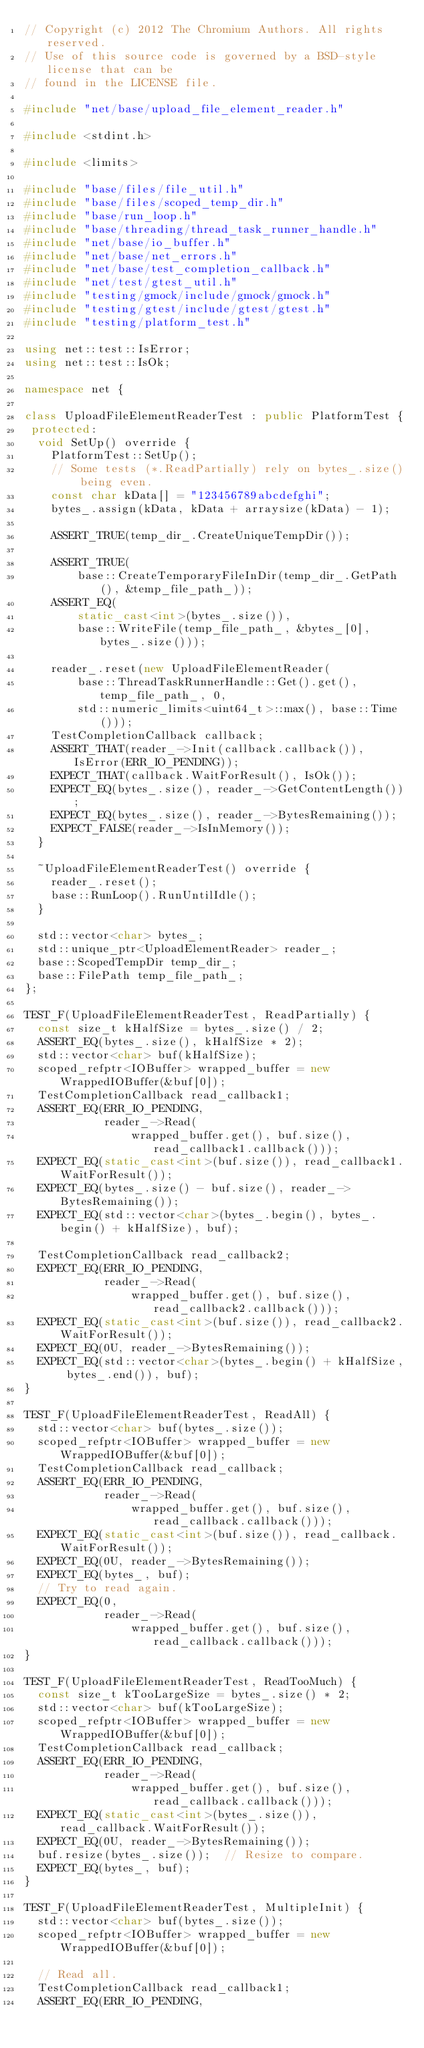<code> <loc_0><loc_0><loc_500><loc_500><_C++_>// Copyright (c) 2012 The Chromium Authors. All rights reserved.
// Use of this source code is governed by a BSD-style license that can be
// found in the LICENSE file.

#include "net/base/upload_file_element_reader.h"

#include <stdint.h>

#include <limits>

#include "base/files/file_util.h"
#include "base/files/scoped_temp_dir.h"
#include "base/run_loop.h"
#include "base/threading/thread_task_runner_handle.h"
#include "net/base/io_buffer.h"
#include "net/base/net_errors.h"
#include "net/base/test_completion_callback.h"
#include "net/test/gtest_util.h"
#include "testing/gmock/include/gmock/gmock.h"
#include "testing/gtest/include/gtest/gtest.h"
#include "testing/platform_test.h"

using net::test::IsError;
using net::test::IsOk;

namespace net {

class UploadFileElementReaderTest : public PlatformTest {
 protected:
  void SetUp() override {
    PlatformTest::SetUp();
    // Some tests (*.ReadPartially) rely on bytes_.size() being even.
    const char kData[] = "123456789abcdefghi";
    bytes_.assign(kData, kData + arraysize(kData) - 1);

    ASSERT_TRUE(temp_dir_.CreateUniqueTempDir());

    ASSERT_TRUE(
        base::CreateTemporaryFileInDir(temp_dir_.GetPath(), &temp_file_path_));
    ASSERT_EQ(
        static_cast<int>(bytes_.size()),
        base::WriteFile(temp_file_path_, &bytes_[0], bytes_.size()));

    reader_.reset(new UploadFileElementReader(
        base::ThreadTaskRunnerHandle::Get().get(), temp_file_path_, 0,
        std::numeric_limits<uint64_t>::max(), base::Time()));
    TestCompletionCallback callback;
    ASSERT_THAT(reader_->Init(callback.callback()), IsError(ERR_IO_PENDING));
    EXPECT_THAT(callback.WaitForResult(), IsOk());
    EXPECT_EQ(bytes_.size(), reader_->GetContentLength());
    EXPECT_EQ(bytes_.size(), reader_->BytesRemaining());
    EXPECT_FALSE(reader_->IsInMemory());
  }

  ~UploadFileElementReaderTest() override {
    reader_.reset();
    base::RunLoop().RunUntilIdle();
  }

  std::vector<char> bytes_;
  std::unique_ptr<UploadElementReader> reader_;
  base::ScopedTempDir temp_dir_;
  base::FilePath temp_file_path_;
};

TEST_F(UploadFileElementReaderTest, ReadPartially) {
  const size_t kHalfSize = bytes_.size() / 2;
  ASSERT_EQ(bytes_.size(), kHalfSize * 2);
  std::vector<char> buf(kHalfSize);
  scoped_refptr<IOBuffer> wrapped_buffer = new WrappedIOBuffer(&buf[0]);
  TestCompletionCallback read_callback1;
  ASSERT_EQ(ERR_IO_PENDING,
            reader_->Read(
                wrapped_buffer.get(), buf.size(), read_callback1.callback()));
  EXPECT_EQ(static_cast<int>(buf.size()), read_callback1.WaitForResult());
  EXPECT_EQ(bytes_.size() - buf.size(), reader_->BytesRemaining());
  EXPECT_EQ(std::vector<char>(bytes_.begin(), bytes_.begin() + kHalfSize), buf);

  TestCompletionCallback read_callback2;
  EXPECT_EQ(ERR_IO_PENDING,
            reader_->Read(
                wrapped_buffer.get(), buf.size(), read_callback2.callback()));
  EXPECT_EQ(static_cast<int>(buf.size()), read_callback2.WaitForResult());
  EXPECT_EQ(0U, reader_->BytesRemaining());
  EXPECT_EQ(std::vector<char>(bytes_.begin() + kHalfSize, bytes_.end()), buf);
}

TEST_F(UploadFileElementReaderTest, ReadAll) {
  std::vector<char> buf(bytes_.size());
  scoped_refptr<IOBuffer> wrapped_buffer = new WrappedIOBuffer(&buf[0]);
  TestCompletionCallback read_callback;
  ASSERT_EQ(ERR_IO_PENDING,
            reader_->Read(
                wrapped_buffer.get(), buf.size(), read_callback.callback()));
  EXPECT_EQ(static_cast<int>(buf.size()), read_callback.WaitForResult());
  EXPECT_EQ(0U, reader_->BytesRemaining());
  EXPECT_EQ(bytes_, buf);
  // Try to read again.
  EXPECT_EQ(0,
            reader_->Read(
                wrapped_buffer.get(), buf.size(), read_callback.callback()));
}

TEST_F(UploadFileElementReaderTest, ReadTooMuch) {
  const size_t kTooLargeSize = bytes_.size() * 2;
  std::vector<char> buf(kTooLargeSize);
  scoped_refptr<IOBuffer> wrapped_buffer = new WrappedIOBuffer(&buf[0]);
  TestCompletionCallback read_callback;
  ASSERT_EQ(ERR_IO_PENDING,
            reader_->Read(
                wrapped_buffer.get(), buf.size(), read_callback.callback()));
  EXPECT_EQ(static_cast<int>(bytes_.size()), read_callback.WaitForResult());
  EXPECT_EQ(0U, reader_->BytesRemaining());
  buf.resize(bytes_.size());  // Resize to compare.
  EXPECT_EQ(bytes_, buf);
}

TEST_F(UploadFileElementReaderTest, MultipleInit) {
  std::vector<char> buf(bytes_.size());
  scoped_refptr<IOBuffer> wrapped_buffer = new WrappedIOBuffer(&buf[0]);

  // Read all.
  TestCompletionCallback read_callback1;
  ASSERT_EQ(ERR_IO_PENDING,</code> 